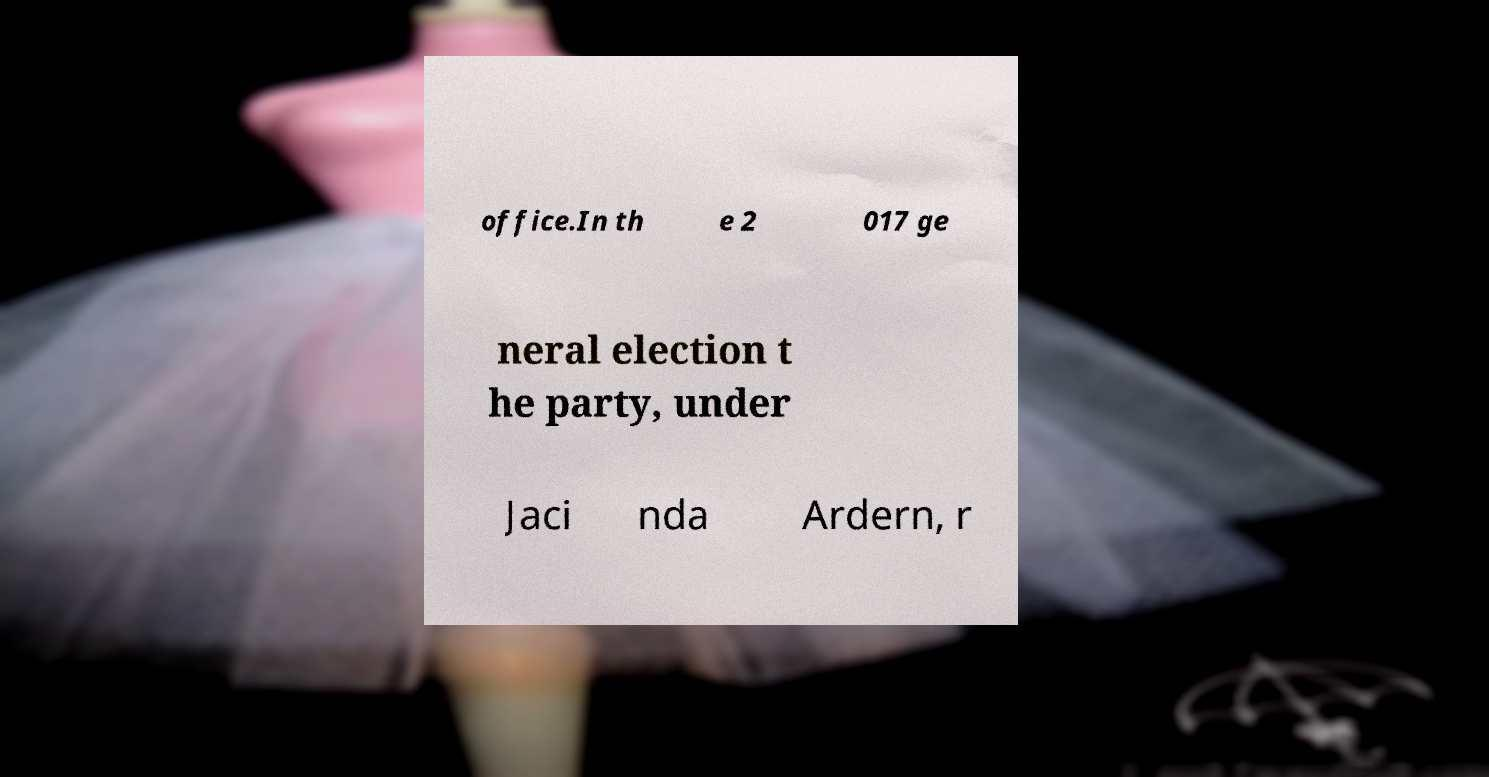Can you read and provide the text displayed in the image?This photo seems to have some interesting text. Can you extract and type it out for me? office.In th e 2 017 ge neral election t he party, under Jaci nda Ardern, r 